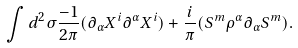<formula> <loc_0><loc_0><loc_500><loc_500>\int d ^ { 2 } \sigma \frac { - 1 } { 2 \pi } ( \partial _ { \alpha } X ^ { i } \partial ^ { \alpha } X ^ { i } ) + \frac { i } { \pi } ( S ^ { m } \rho ^ { \alpha } \partial _ { \alpha } S ^ { m } ) .</formula> 